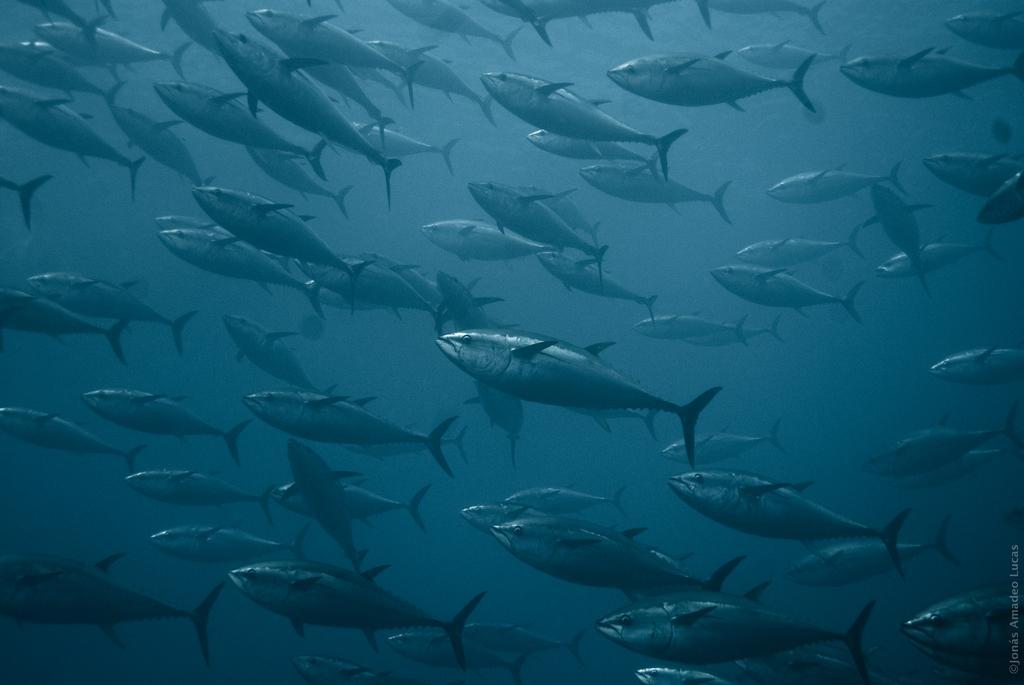Please provide a concise description of this image. In this image, we can see there are fish in the water. On the bottom right, there is a watermark. And the background of this water is gray in color. 